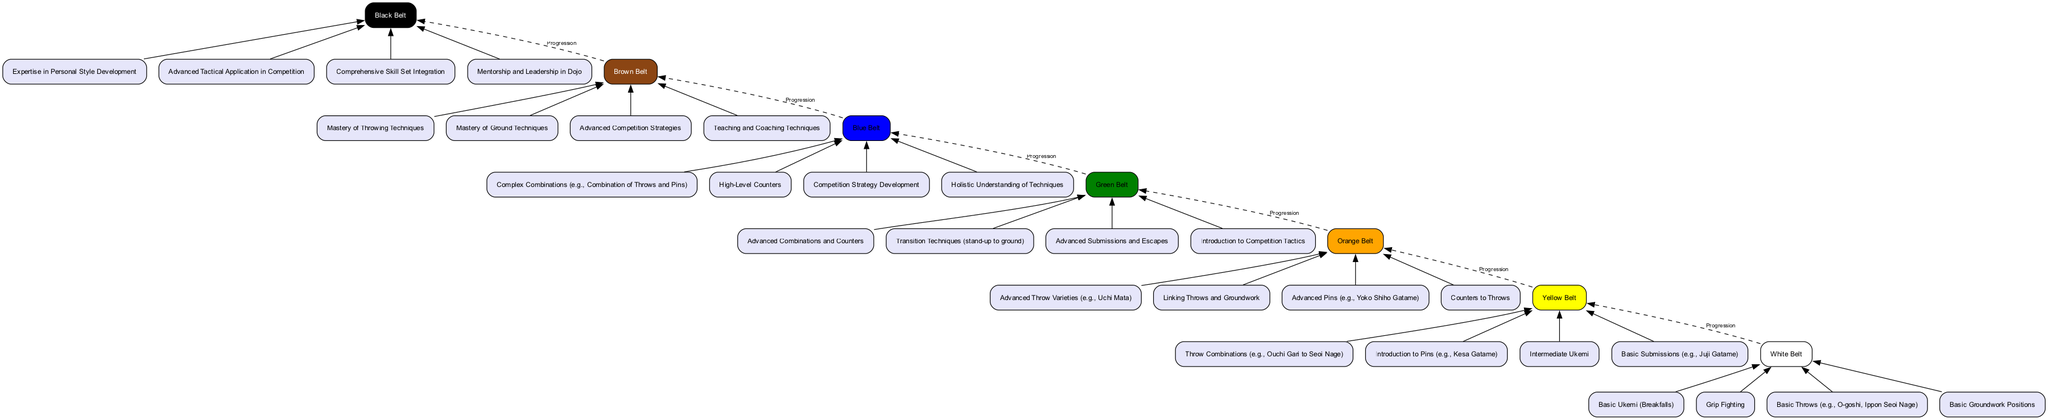What is the highest belt level depicted in the diagram? The highest belt level is identified by the top node in the diagram. In this case, it is the "Black Belt."
Answer: Black Belt How many skill sets are associated with the Green Belt? By counting the skills listed for the Green Belt node, we find that there are four skill sets associated with it.
Answer: 4 What is the connection type between the Orange Belt and the Green Belt? The connection between the Orange Belt and the Green Belt is represented by a dashed line labeled "Progression," indicating a sequential relationship.
Answer: Progression Which skill is listed under the Yellow Belt? The skills associated with the Yellow Belt can be located beneath it. One example of a skill listed is "Basic Submissions (e.g., Juji Gatame)."
Answer: Basic Submissions (e.g., Juji Gatame) What is the main focus of the skills at the Black Belt level? The skills at the Black Belt level describe advanced topics, focusing primarily on "Expertise in Personal Style Development" among other expert-level skills.
Answer: Expertise in Personal Style Development How many total belts are represented in the diagram? The total number of belts can be counted by reviewing each unique belt node in the diagram. There are seven distinct belt levels present.
Answer: 7 What is the last skill listed for the Blue Belt? On examining the skills under the Blue Belt, the last skill listed is "Holistic Understanding of Techniques."
Answer: Holistic Understanding of Techniques What type of techniques are emphasized at the Brown Belt level? The Brown Belt level emphasizes mastery in both throwing and ground techniques, described as "Mastery of Throwing Techniques" and "Mastery of Ground Techniques."
Answer: Mastery of Throwing Techniques Which belt level introduces "Introduction to Competition Tactics"? "Introduction to Competition Tactics" is a skill associated with the Green Belt, indicating it is introduced at this level of training.
Answer: Green Belt 